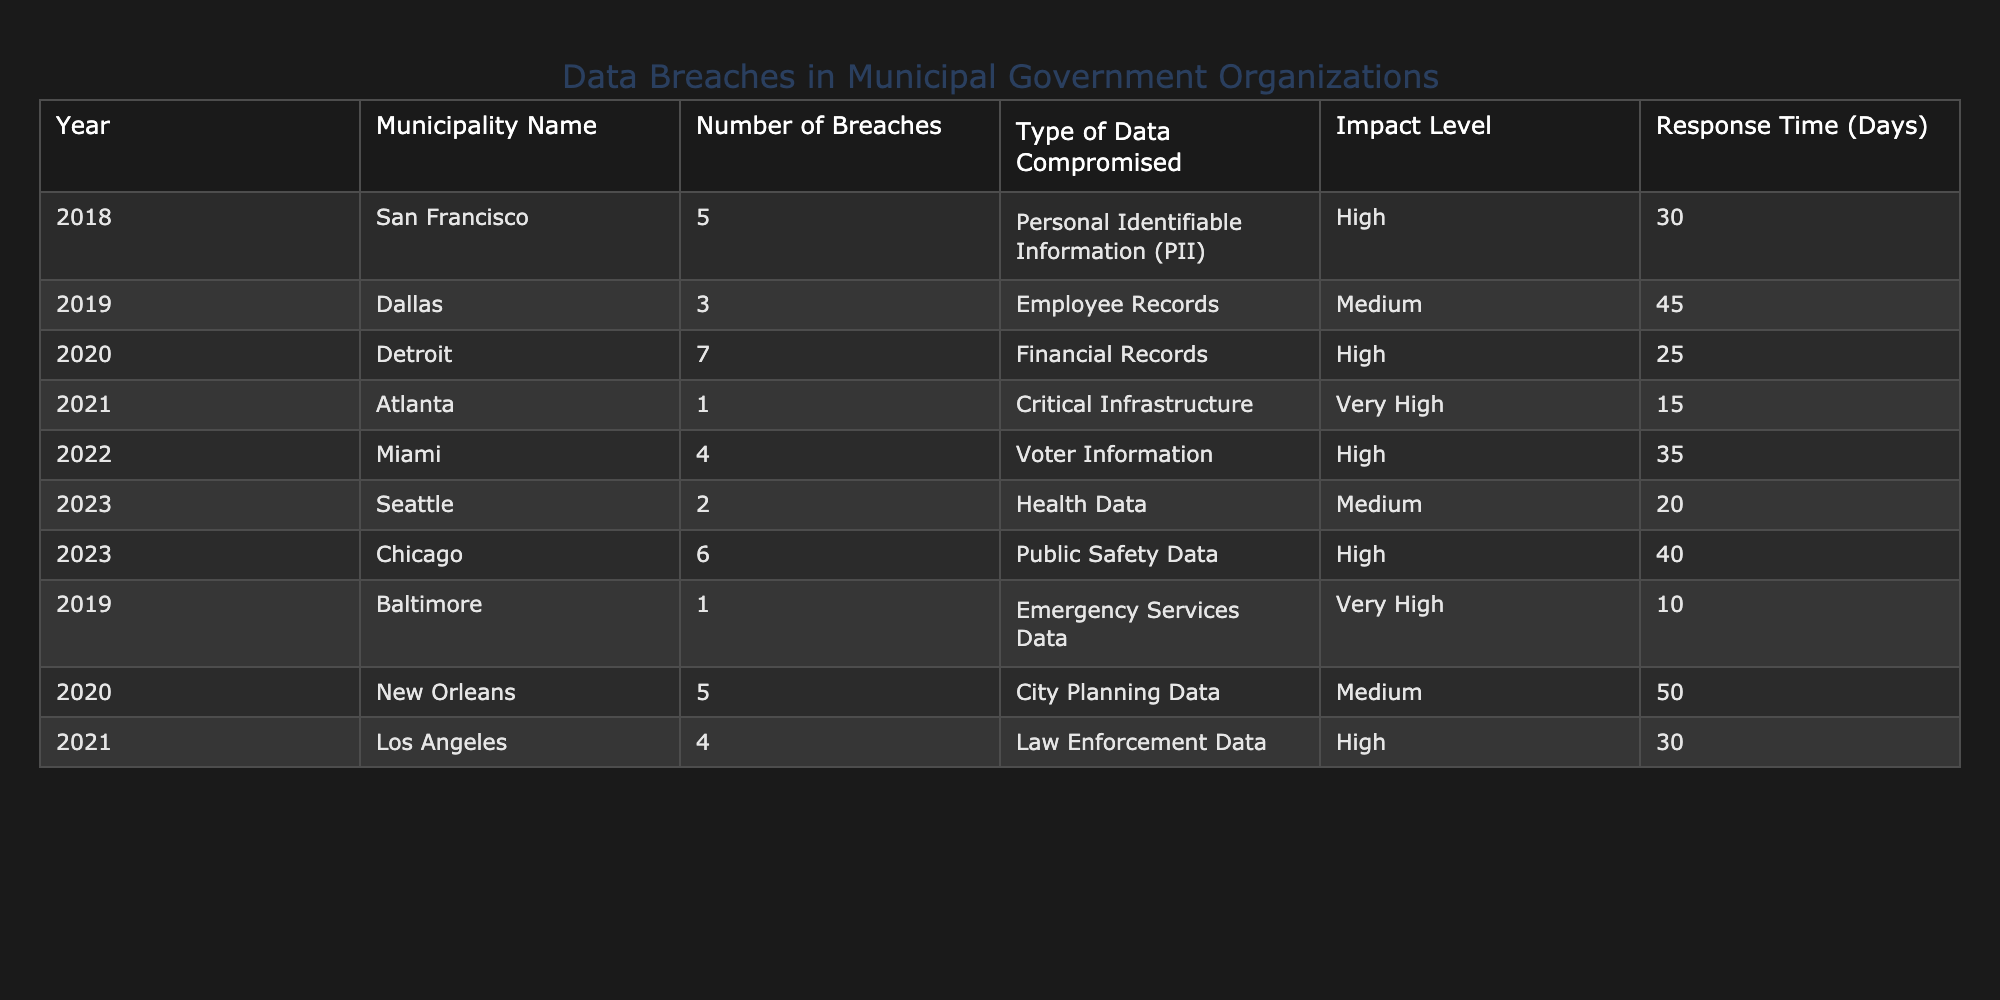What municipality had the highest number of data breaches? The table shows that Detroit had the highest number of breaches, with a total of 7 breaches in 2020.
Answer: Detroit How many breaches occurred in 2023 across all municipalities? By looking at the table, there were 2 breaches in Seattle and 6 in Chicago, which totals to 8 breaches for the year 2023.
Answer: 8 True or False: Atlanta had a very high impact level event in 2021. The table indicates that Atlanta had one breach in 2021, and its impact level was categorized as very high. Therefore, this statement is true.
Answer: True What type of data was most frequently compromised in the breaches reported? The table reveals various types of compromised data, including PII, employee records, financial records, and others. However, the most common data type (if counted by their occurrences) would need to be tallied. There are 2 instances of High Impact PII based on the provided data.
Answer: PII and other types vary What is the average response time for breaches in 2019? In 2019, there were typically three municipalities listed: Dallas with 45 days, Baltimore with 10 days, and the average is calculated as (45 + 10) / 2 = 27.5 days. Therefore, after rounding, the average response time for that year is approximately 28 days.
Answer: 28 days Which municipality took the longest to respond to a data breach? From the table, New Orleans took the longest response time with 50 days, as listed for the breach in 2020.
Answer: New Orleans How many municipalities experienced breaches related to health data? The table specifies that only one municipality, Seattle, experienced a breach related to health data in 2023, as evidenced by the corresponding entry in the table.
Answer: 1 What is the total number of breaches from the municipalities listed in 2020? For 2020, the table lists Detroit with 7 breaches and New Orleans with 5 breaches. Adding them together gives 7 + 5 = 12 breaches in total for that year.
Answer: 12 Which municipality had the fewest breaches over the provided years? Reviewing the entire table, Atlanta reported just one breach in 2021, therefore making it the municipality with the fewest breaches recorded.
Answer: Atlanta 